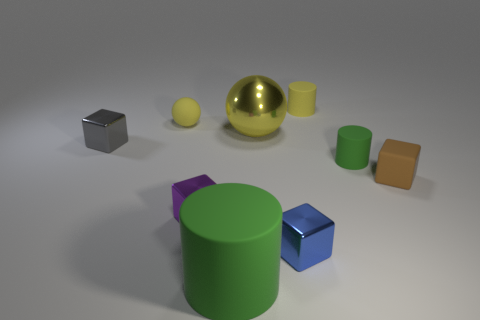What shape is the tiny brown object that is made of the same material as the small green thing? The tiny brown object, which shares the same matte finish as the small green cylinder, is a cube. It has six faces, each a square of the same size. 